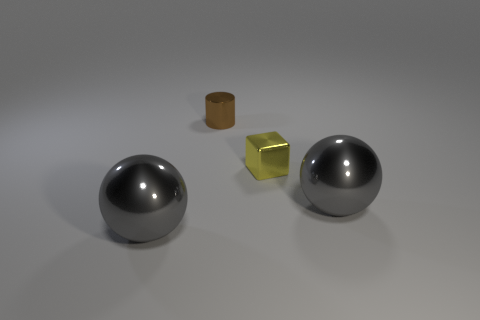What is the thing that is both left of the yellow object and in front of the small metallic cylinder made of?
Ensure brevity in your answer.  Metal. Does the gray metal object on the right side of the cylinder have the same size as the tiny brown thing?
Ensure brevity in your answer.  No. What is the shape of the brown object that is the same size as the yellow block?
Provide a succinct answer. Cylinder. Do the yellow metallic thing and the brown object have the same shape?
Your answer should be very brief. No. How many large gray objects have the same shape as the small yellow metallic thing?
Your response must be concise. 0. What number of big gray balls are to the left of the tiny yellow block?
Offer a terse response. 1. What number of yellow objects are the same size as the cylinder?
Give a very brief answer. 1. The small thing that is made of the same material as the tiny yellow cube is what shape?
Keep it short and to the point. Cylinder. What number of objects are gray shiny objects or metal things?
Offer a terse response. 4. There is a brown thing behind the tiny yellow shiny cube; what size is it?
Give a very brief answer. Small. 